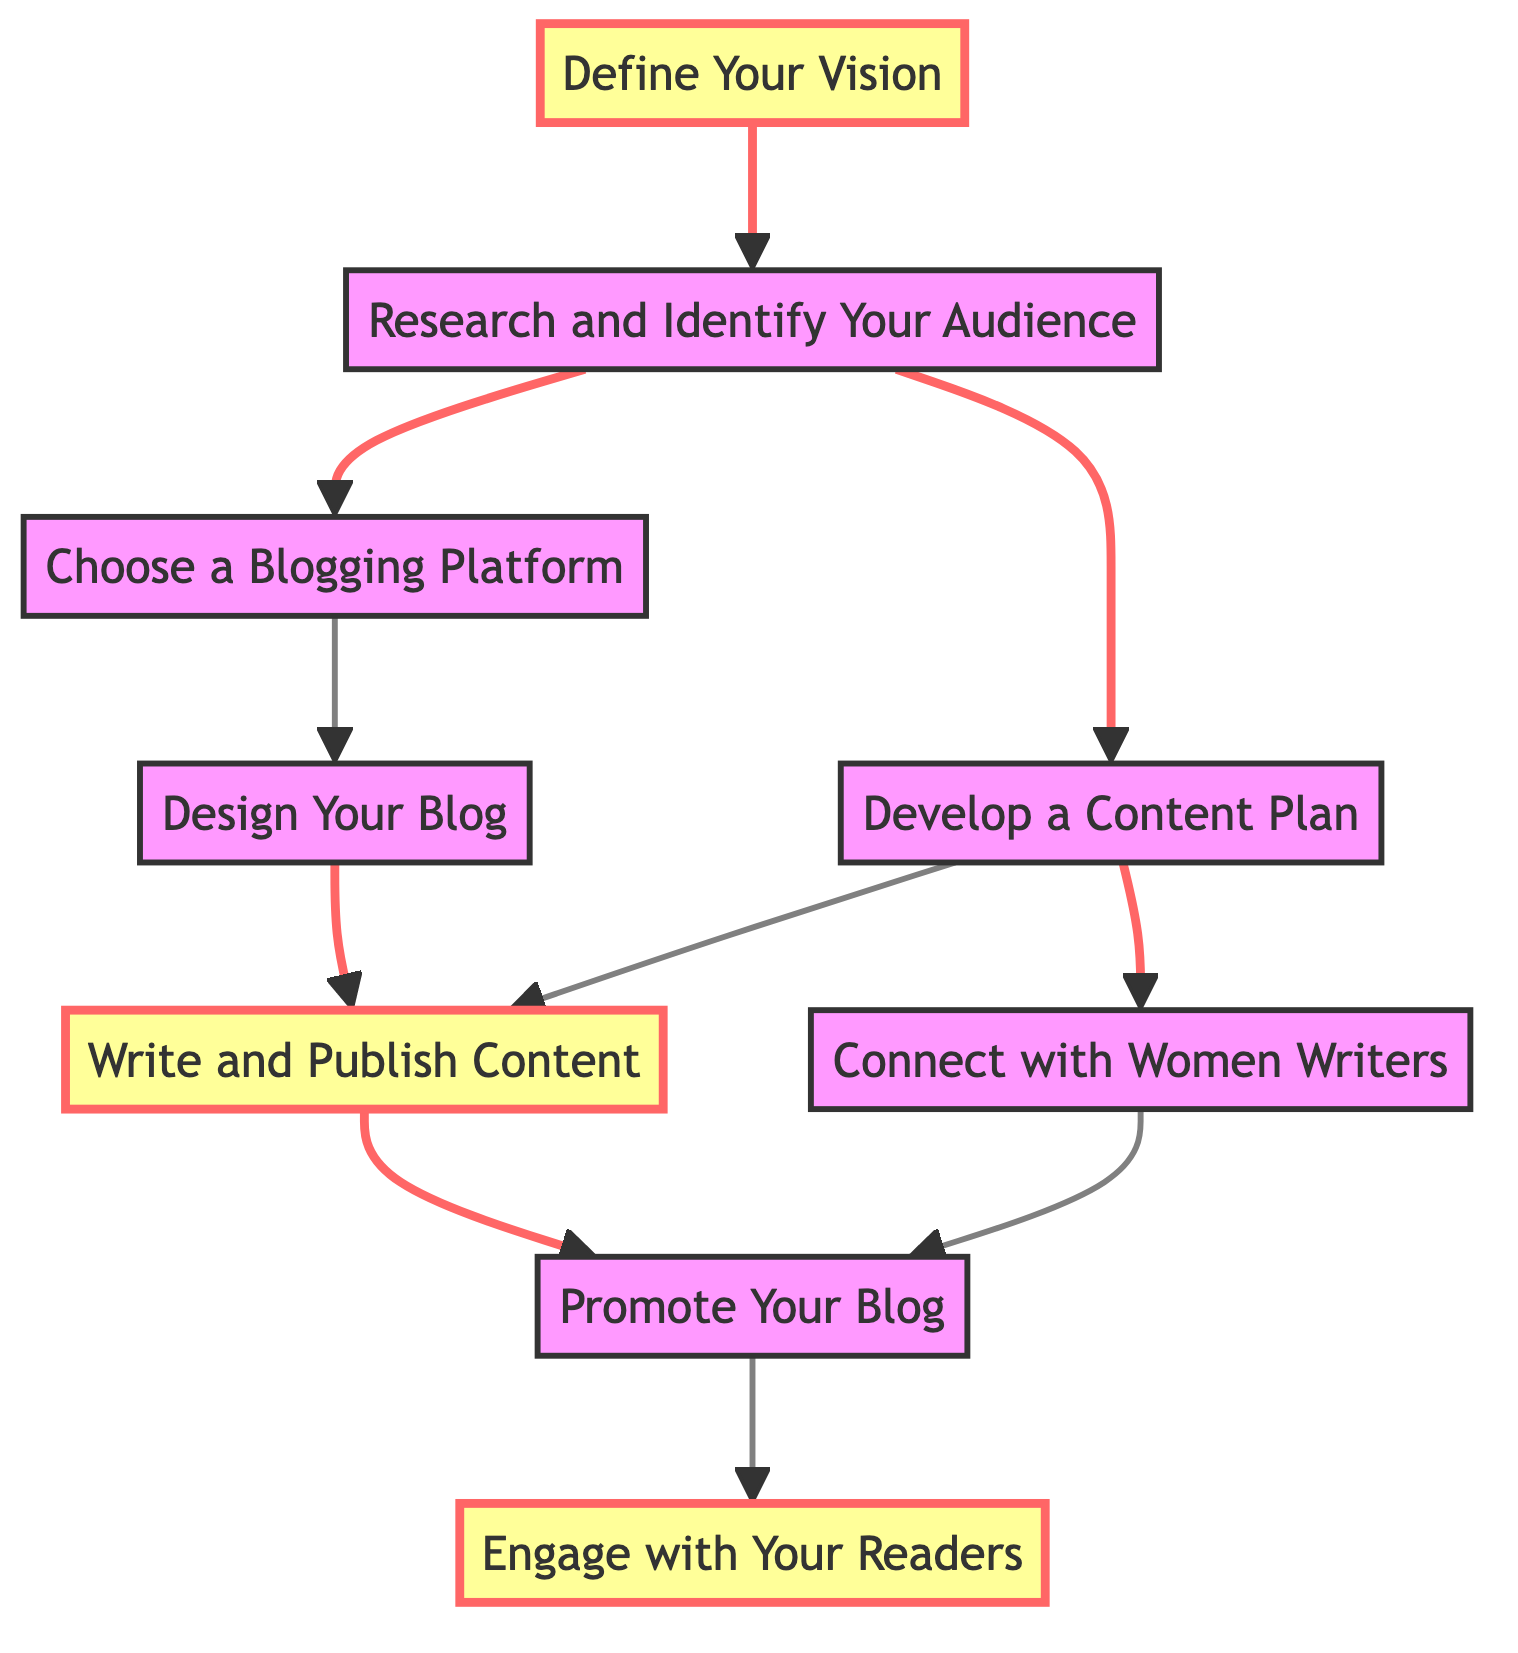What is the first step to start a literary blog? The diagram starts with "Define Your Vision" as the first node that outlines the purpose of the blog.
Answer: Define Your Vision How many steps are there in total in the flowchart? Counting all the distinct nodes in the diagram, there are 9 steps in total, indicating the phases in starting the blog.
Answer: 9 What follows after "Research and Identify Your Audience"? The diagram shows two paths from this step; it can lead to either "Choose a Blogging Platform" or "Develop a Content Plan."
Answer: Choose a Blogging Platform / Develop a Content Plan Which step is essential for creating content? The step "Write and Publish Content" is essential as it directly involves creating the blog posts.
Answer: Write and Publish Content What two steps lead to promoting the blog? The steps leading to "Promote Your Blog" are "Write and Publish Content" and "Connect with Women Writers."
Answer: Write and Publish Content, Connect with Women Writers What is the final step in this flowchart? The final node in the diagram is "Engage with Your Readers," emphasizing community interaction.
Answer: Engage with Your Readers Which step has the most connections to other steps? The step "Research and Identify Your Audience" has the most connections, leading to two different paths further along the flowchart.
Answer: Research and Identify Your Audience Which node highlights the importance of networking in this process? The "Connect with Women Writers" step emphasizes the importance of networking with authors to feature their works.
Answer: Connect with Women Writers What action should be taken after writing and publishing content? After writing and publishing, the next step is to "Promote Your Blog" to reach a broader audience.
Answer: Promote Your Blog 